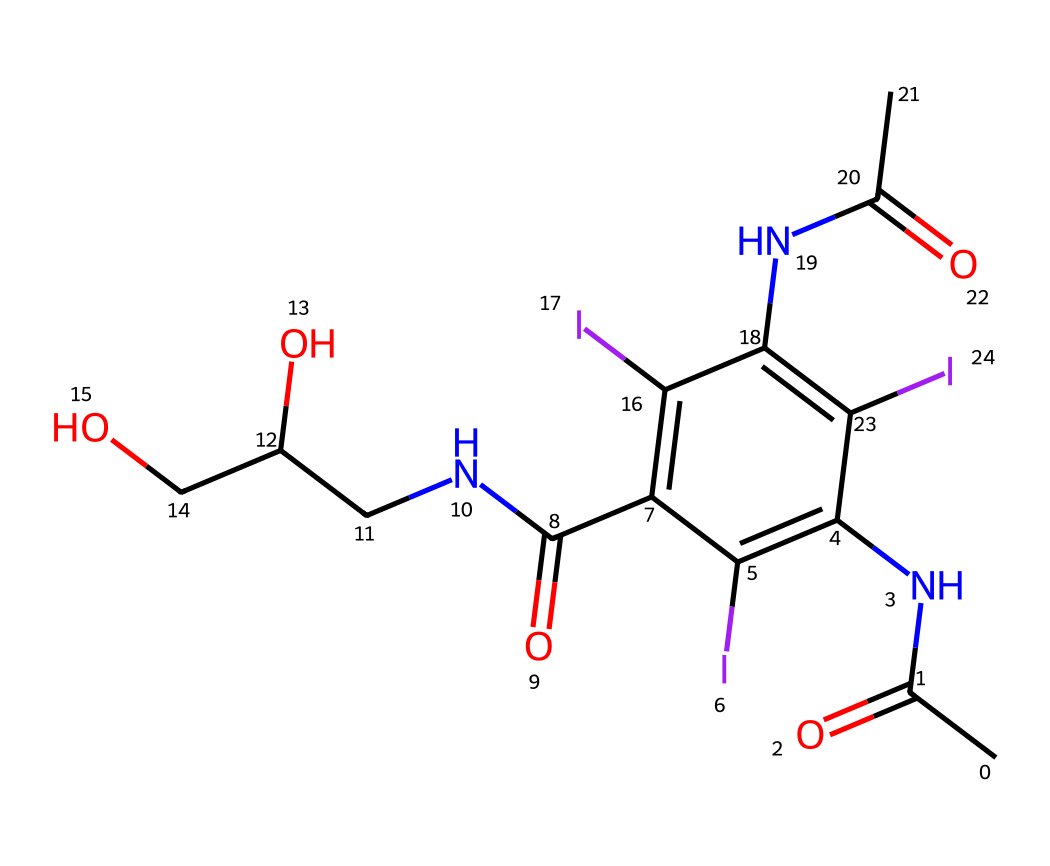What is the total number of iodine atoms in this chemical? By inspecting the SMILES representation, we can count the occurrences of the letter "I," which corresponds to iodine atoms. In this case, there are three instances of "I."
Answer: three How many carbon atoms are present in this compound? The SMILES representation contains occurrences of "C," which denotes carbon atoms. Counting these occurrences, we find there are eight carbon atoms in total.
Answer: eight What type of functional group is represented by "NC" in this compound? The "NC" indicates the presence of an amine functional group, as it consists of a nitrogen atom bonded to a carbon atom.
Answer: amine What is the degree of unsaturation in this chemical? To determine the degree of unsaturation, we can use the formula U = 1 + C/2 - (H/2) - (X/2), where C is the number of carbons, H is the number of hydrogens, and X is the number of halogens. From our analysis, we have C=8, H=12, and X=3, giving U = 1 + 8/2 - (12/2) - (3/2) = 0, indicating no rings or double bonds.
Answer: zero Which elements in this compound are likely to provide radiopacity for imaging? Radiopacity in imaging agents typically comes from heavier elements. Here, iodine (I) is a heavy halogen and is the key element contributing to the radiopacity in this contrast agent.
Answer: iodine How many amino groups are present in this chemical structure? In the SMILES, we identify the presence of "NH" groups; counting these reveals two amino groups present in the structure.
Answer: two 